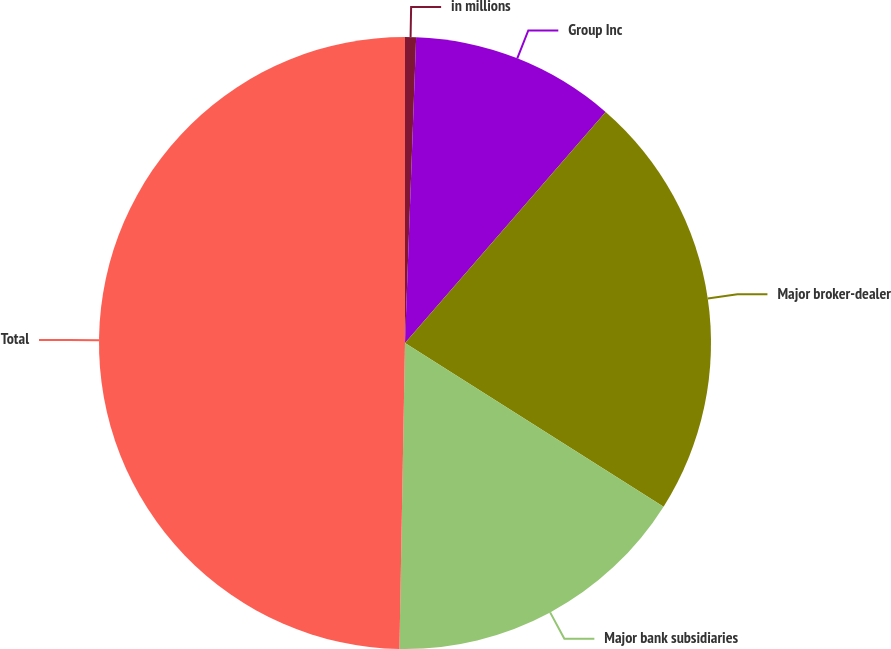<chart> <loc_0><loc_0><loc_500><loc_500><pie_chart><fcel>in millions<fcel>Group Inc<fcel>Major broker-dealer<fcel>Major bank subsidiaries<fcel>Total<nl><fcel>0.58%<fcel>10.8%<fcel>22.6%<fcel>16.31%<fcel>49.71%<nl></chart> 